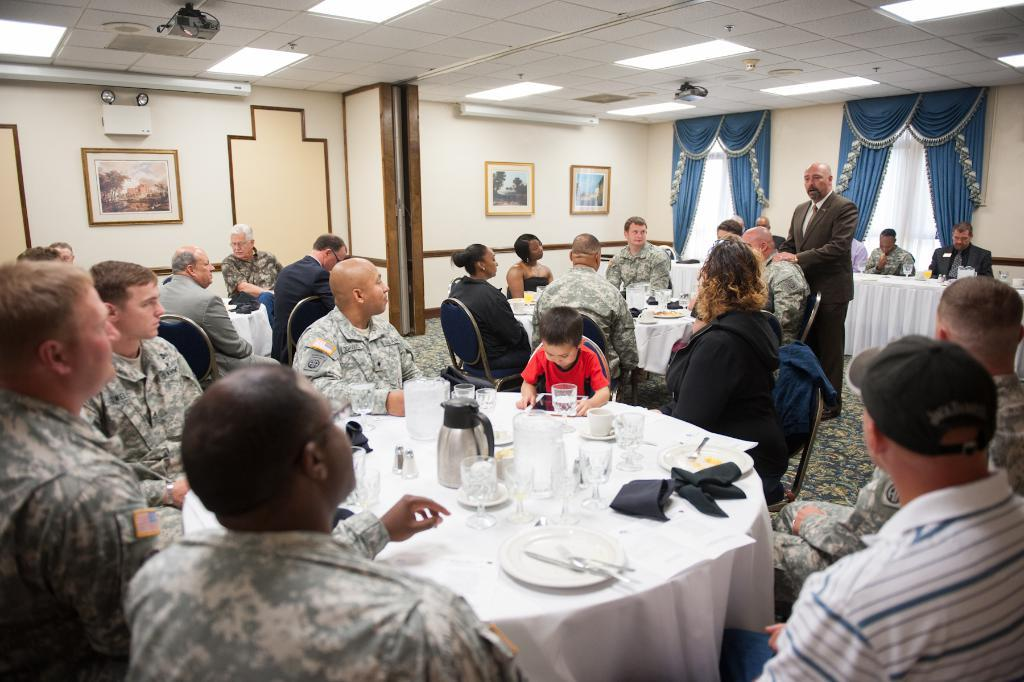What are the people in the image doing? The people in the image are sitting in groups at tables. Is there anyone standing in the image? Yes, a man is standing and speaking. What is the man's role in the image? The people are listening to the man, so he is likely a speaker or presenter. How many kitties are sitting on the tables in the image? There are no kitties present in the image. What type of stamp is being used by the man while speaking? There is no stamp visible in the image, and the man is not using one while speaking. 